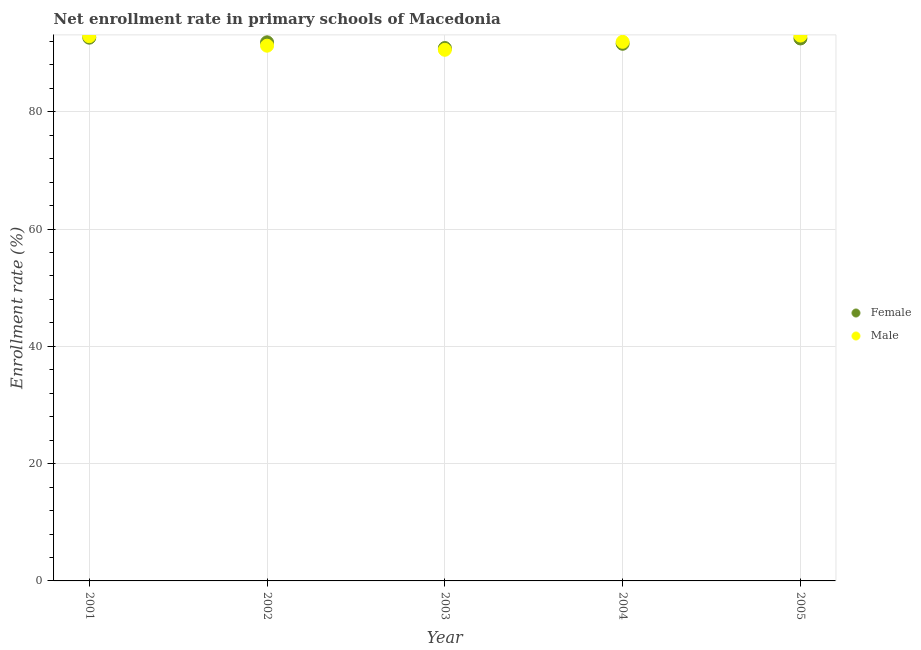How many different coloured dotlines are there?
Offer a terse response. 2. What is the enrollment rate of male students in 2005?
Offer a terse response. 92.98. Across all years, what is the maximum enrollment rate of female students?
Ensure brevity in your answer.  92.62. Across all years, what is the minimum enrollment rate of male students?
Provide a short and direct response. 90.56. What is the total enrollment rate of male students in the graph?
Keep it short and to the point. 459.59. What is the difference between the enrollment rate of female students in 2001 and that in 2003?
Ensure brevity in your answer.  1.77. What is the difference between the enrollment rate of male students in 2001 and the enrollment rate of female students in 2004?
Offer a terse response. 1.29. What is the average enrollment rate of male students per year?
Make the answer very short. 91.92. In the year 2004, what is the difference between the enrollment rate of female students and enrollment rate of male students?
Ensure brevity in your answer.  -0.33. What is the ratio of the enrollment rate of female students in 2002 to that in 2005?
Offer a very short reply. 0.99. Is the enrollment rate of male students in 2004 less than that in 2005?
Keep it short and to the point. Yes. Is the difference between the enrollment rate of male students in 2001 and 2003 greater than the difference between the enrollment rate of female students in 2001 and 2003?
Provide a succinct answer. Yes. What is the difference between the highest and the second highest enrollment rate of male students?
Offer a very short reply. 0.1. What is the difference between the highest and the lowest enrollment rate of male students?
Make the answer very short. 2.42. Is the sum of the enrollment rate of male students in 2004 and 2005 greater than the maximum enrollment rate of female students across all years?
Your answer should be very brief. Yes. Is the enrollment rate of male students strictly greater than the enrollment rate of female students over the years?
Provide a succinct answer. No. How many dotlines are there?
Your answer should be very brief. 2. How many years are there in the graph?
Offer a very short reply. 5. Are the values on the major ticks of Y-axis written in scientific E-notation?
Make the answer very short. No. Does the graph contain any zero values?
Offer a very short reply. No. Does the graph contain grids?
Offer a terse response. Yes. Where does the legend appear in the graph?
Keep it short and to the point. Center right. How are the legend labels stacked?
Offer a terse response. Vertical. What is the title of the graph?
Your answer should be compact. Net enrollment rate in primary schools of Macedonia. Does "Depositors" appear as one of the legend labels in the graph?
Your answer should be compact. No. What is the label or title of the X-axis?
Provide a succinct answer. Year. What is the label or title of the Y-axis?
Ensure brevity in your answer.  Enrollment rate (%). What is the Enrollment rate (%) in Female in 2001?
Ensure brevity in your answer.  92.62. What is the Enrollment rate (%) of Male in 2001?
Make the answer very short. 92.88. What is the Enrollment rate (%) of Female in 2002?
Make the answer very short. 91.83. What is the Enrollment rate (%) in Male in 2002?
Your answer should be very brief. 91.26. What is the Enrollment rate (%) in Female in 2003?
Offer a very short reply. 90.86. What is the Enrollment rate (%) of Male in 2003?
Make the answer very short. 90.56. What is the Enrollment rate (%) in Female in 2004?
Your answer should be compact. 91.58. What is the Enrollment rate (%) in Male in 2004?
Provide a succinct answer. 91.92. What is the Enrollment rate (%) in Female in 2005?
Keep it short and to the point. 92.49. What is the Enrollment rate (%) in Male in 2005?
Provide a succinct answer. 92.98. Across all years, what is the maximum Enrollment rate (%) of Female?
Your answer should be very brief. 92.62. Across all years, what is the maximum Enrollment rate (%) of Male?
Ensure brevity in your answer.  92.98. Across all years, what is the minimum Enrollment rate (%) in Female?
Provide a short and direct response. 90.86. Across all years, what is the minimum Enrollment rate (%) of Male?
Offer a very short reply. 90.56. What is the total Enrollment rate (%) of Female in the graph?
Give a very brief answer. 459.39. What is the total Enrollment rate (%) in Male in the graph?
Offer a very short reply. 459.59. What is the difference between the Enrollment rate (%) in Female in 2001 and that in 2002?
Make the answer very short. 0.79. What is the difference between the Enrollment rate (%) in Male in 2001 and that in 2002?
Keep it short and to the point. 1.62. What is the difference between the Enrollment rate (%) of Female in 2001 and that in 2003?
Your answer should be very brief. 1.77. What is the difference between the Enrollment rate (%) of Male in 2001 and that in 2003?
Your answer should be compact. 2.32. What is the difference between the Enrollment rate (%) in Female in 2001 and that in 2004?
Provide a succinct answer. 1.04. What is the difference between the Enrollment rate (%) in Male in 2001 and that in 2004?
Offer a terse response. 0.96. What is the difference between the Enrollment rate (%) of Female in 2001 and that in 2005?
Offer a terse response. 0.13. What is the difference between the Enrollment rate (%) in Male in 2001 and that in 2005?
Ensure brevity in your answer.  -0.1. What is the difference between the Enrollment rate (%) in Female in 2002 and that in 2003?
Give a very brief answer. 0.97. What is the difference between the Enrollment rate (%) of Male in 2002 and that in 2003?
Make the answer very short. 0.7. What is the difference between the Enrollment rate (%) of Female in 2002 and that in 2004?
Ensure brevity in your answer.  0.25. What is the difference between the Enrollment rate (%) in Male in 2002 and that in 2004?
Provide a succinct answer. -0.66. What is the difference between the Enrollment rate (%) in Female in 2002 and that in 2005?
Provide a succinct answer. -0.66. What is the difference between the Enrollment rate (%) in Male in 2002 and that in 2005?
Ensure brevity in your answer.  -1.72. What is the difference between the Enrollment rate (%) in Female in 2003 and that in 2004?
Keep it short and to the point. -0.73. What is the difference between the Enrollment rate (%) in Male in 2003 and that in 2004?
Your response must be concise. -1.36. What is the difference between the Enrollment rate (%) of Female in 2003 and that in 2005?
Your answer should be compact. -1.63. What is the difference between the Enrollment rate (%) of Male in 2003 and that in 2005?
Make the answer very short. -2.42. What is the difference between the Enrollment rate (%) of Female in 2004 and that in 2005?
Make the answer very short. -0.91. What is the difference between the Enrollment rate (%) of Male in 2004 and that in 2005?
Offer a very short reply. -1.06. What is the difference between the Enrollment rate (%) of Female in 2001 and the Enrollment rate (%) of Male in 2002?
Offer a terse response. 1.37. What is the difference between the Enrollment rate (%) of Female in 2001 and the Enrollment rate (%) of Male in 2003?
Give a very brief answer. 2.07. What is the difference between the Enrollment rate (%) in Female in 2001 and the Enrollment rate (%) in Male in 2004?
Provide a succinct answer. 0.71. What is the difference between the Enrollment rate (%) of Female in 2001 and the Enrollment rate (%) of Male in 2005?
Ensure brevity in your answer.  -0.36. What is the difference between the Enrollment rate (%) of Female in 2002 and the Enrollment rate (%) of Male in 2003?
Your response must be concise. 1.27. What is the difference between the Enrollment rate (%) of Female in 2002 and the Enrollment rate (%) of Male in 2004?
Offer a very short reply. -0.08. What is the difference between the Enrollment rate (%) in Female in 2002 and the Enrollment rate (%) in Male in 2005?
Offer a very short reply. -1.15. What is the difference between the Enrollment rate (%) in Female in 2003 and the Enrollment rate (%) in Male in 2004?
Ensure brevity in your answer.  -1.06. What is the difference between the Enrollment rate (%) in Female in 2003 and the Enrollment rate (%) in Male in 2005?
Give a very brief answer. -2.12. What is the difference between the Enrollment rate (%) in Female in 2004 and the Enrollment rate (%) in Male in 2005?
Your response must be concise. -1.4. What is the average Enrollment rate (%) of Female per year?
Give a very brief answer. 91.88. What is the average Enrollment rate (%) in Male per year?
Your answer should be compact. 91.92. In the year 2001, what is the difference between the Enrollment rate (%) in Female and Enrollment rate (%) in Male?
Your answer should be compact. -0.25. In the year 2002, what is the difference between the Enrollment rate (%) in Female and Enrollment rate (%) in Male?
Keep it short and to the point. 0.57. In the year 2003, what is the difference between the Enrollment rate (%) of Female and Enrollment rate (%) of Male?
Give a very brief answer. 0.3. In the year 2004, what is the difference between the Enrollment rate (%) of Female and Enrollment rate (%) of Male?
Ensure brevity in your answer.  -0.33. In the year 2005, what is the difference between the Enrollment rate (%) in Female and Enrollment rate (%) in Male?
Make the answer very short. -0.49. What is the ratio of the Enrollment rate (%) in Female in 2001 to that in 2002?
Provide a short and direct response. 1.01. What is the ratio of the Enrollment rate (%) of Male in 2001 to that in 2002?
Make the answer very short. 1.02. What is the ratio of the Enrollment rate (%) in Female in 2001 to that in 2003?
Keep it short and to the point. 1.02. What is the ratio of the Enrollment rate (%) of Male in 2001 to that in 2003?
Make the answer very short. 1.03. What is the ratio of the Enrollment rate (%) in Female in 2001 to that in 2004?
Ensure brevity in your answer.  1.01. What is the ratio of the Enrollment rate (%) in Male in 2001 to that in 2004?
Keep it short and to the point. 1.01. What is the ratio of the Enrollment rate (%) of Female in 2001 to that in 2005?
Give a very brief answer. 1. What is the ratio of the Enrollment rate (%) in Male in 2001 to that in 2005?
Your answer should be compact. 1. What is the ratio of the Enrollment rate (%) in Female in 2002 to that in 2003?
Offer a very short reply. 1.01. What is the ratio of the Enrollment rate (%) in Male in 2002 to that in 2003?
Keep it short and to the point. 1.01. What is the ratio of the Enrollment rate (%) in Female in 2002 to that in 2004?
Your answer should be compact. 1. What is the ratio of the Enrollment rate (%) of Male in 2002 to that in 2004?
Make the answer very short. 0.99. What is the ratio of the Enrollment rate (%) in Male in 2002 to that in 2005?
Make the answer very short. 0.98. What is the ratio of the Enrollment rate (%) of Male in 2003 to that in 2004?
Offer a very short reply. 0.99. What is the ratio of the Enrollment rate (%) of Female in 2003 to that in 2005?
Make the answer very short. 0.98. What is the ratio of the Enrollment rate (%) of Male in 2003 to that in 2005?
Offer a terse response. 0.97. What is the ratio of the Enrollment rate (%) in Female in 2004 to that in 2005?
Offer a terse response. 0.99. What is the difference between the highest and the second highest Enrollment rate (%) in Female?
Make the answer very short. 0.13. What is the difference between the highest and the second highest Enrollment rate (%) in Male?
Give a very brief answer. 0.1. What is the difference between the highest and the lowest Enrollment rate (%) of Female?
Ensure brevity in your answer.  1.77. What is the difference between the highest and the lowest Enrollment rate (%) of Male?
Offer a terse response. 2.42. 